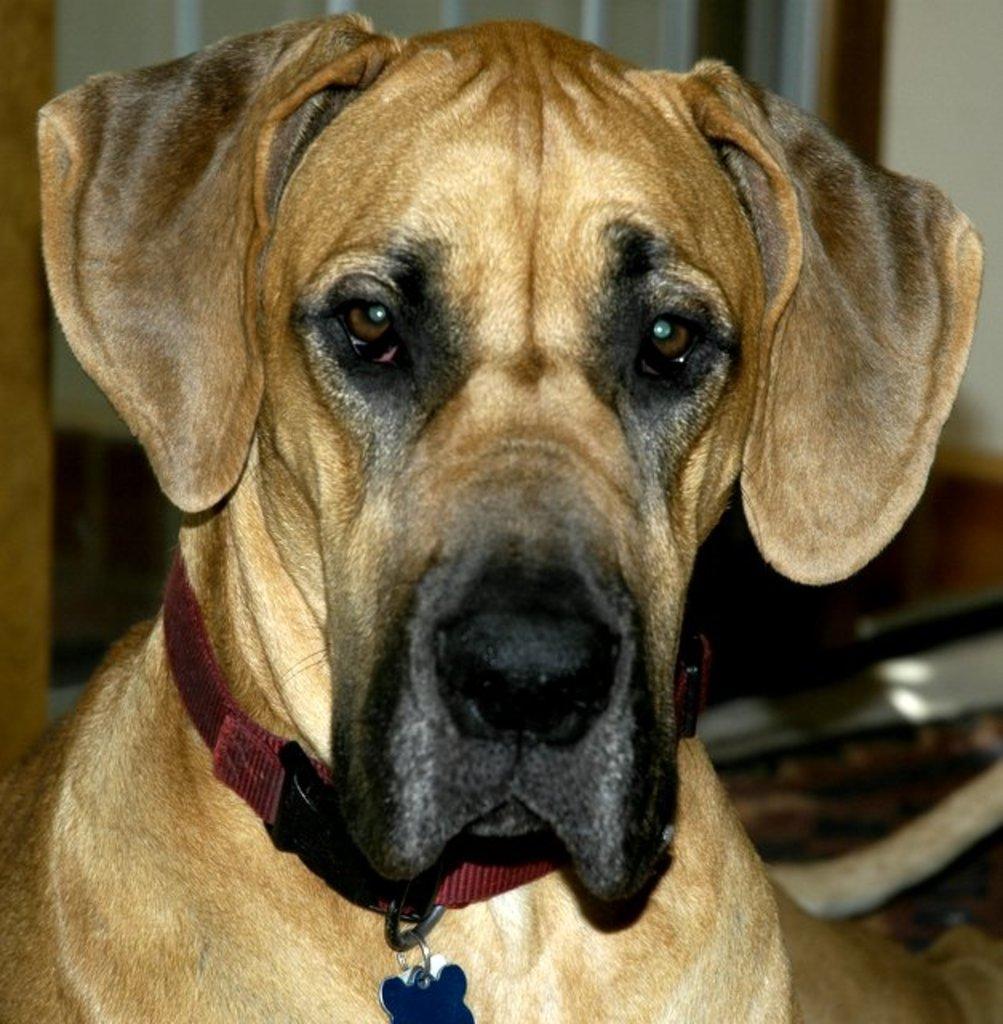How would you summarize this image in a sentence or two? In this image we can see a dog who is in brown color and collar is attached to the neck of the dog. 